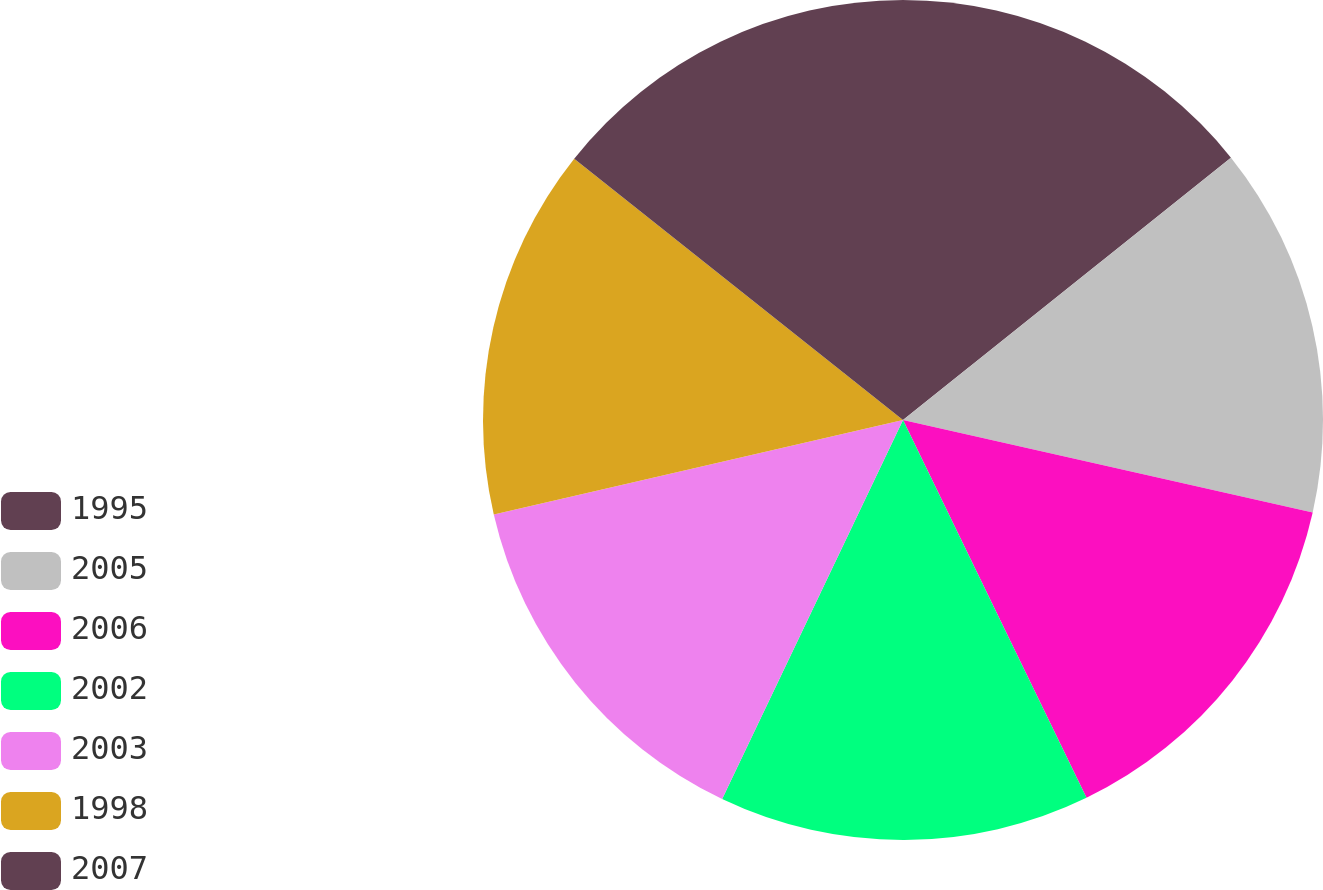<chart> <loc_0><loc_0><loc_500><loc_500><pie_chart><fcel>1995<fcel>2005<fcel>2006<fcel>2002<fcel>2003<fcel>1998<fcel>2007<nl><fcel>14.26%<fcel>14.27%<fcel>14.27%<fcel>14.28%<fcel>14.3%<fcel>14.3%<fcel>14.31%<nl></chart> 